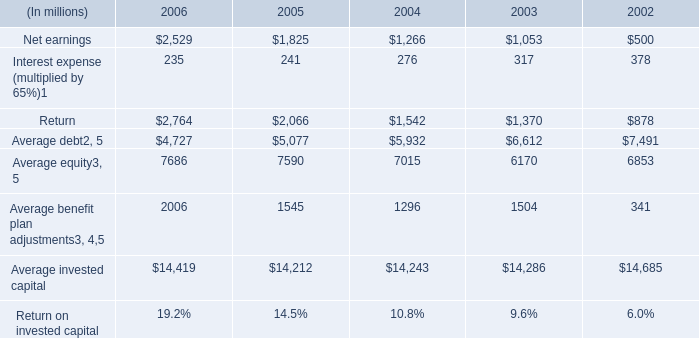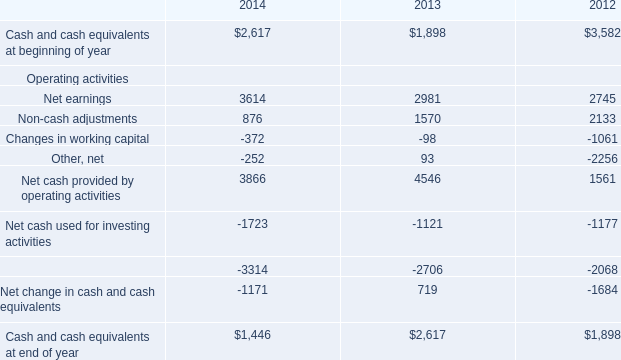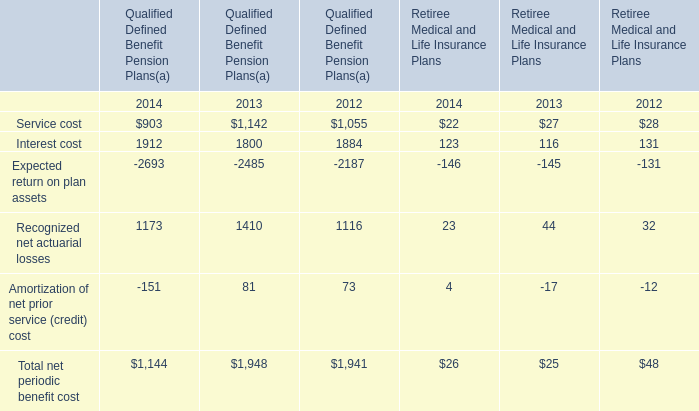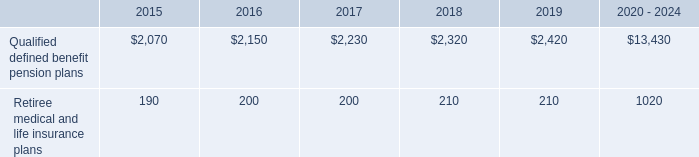What is the total amount of Other, net Operating activities of 2012, Net earnings of 2003, and Net cash used for financing activities Operating activities of 2012 ? 
Computations: ((2256.0 + 1053.0) + 2068.0)
Answer: 5377.0. 